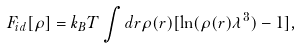<formula> <loc_0><loc_0><loc_500><loc_500>F _ { i d } [ \rho ] = k _ { B } T \int d { r } \rho ( { r } ) [ \ln ( \rho ( { r } ) \lambda ^ { 3 } ) - 1 ] ,</formula> 